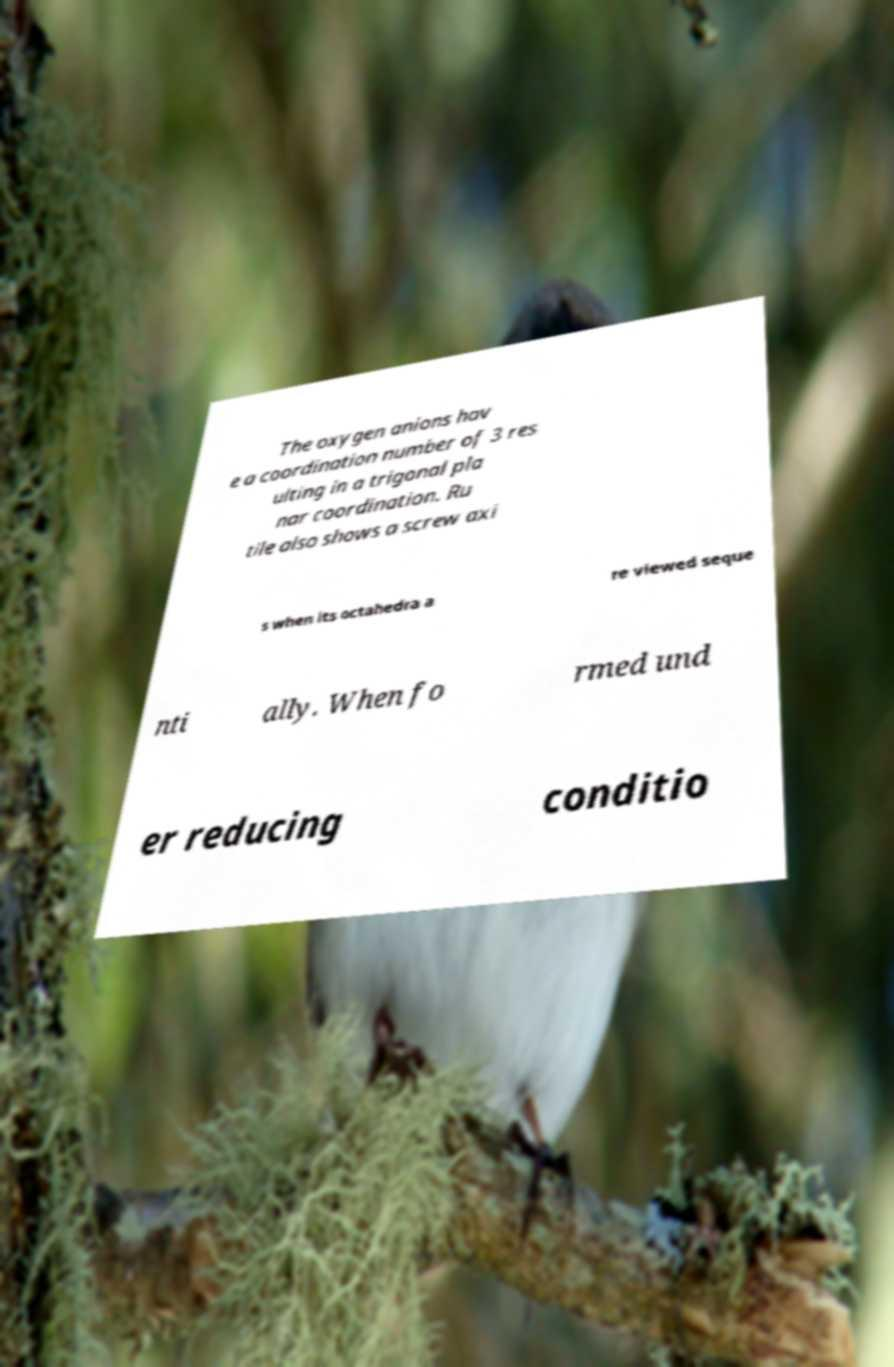Can you accurately transcribe the text from the provided image for me? The oxygen anions hav e a coordination number of 3 res ulting in a trigonal pla nar coordination. Ru tile also shows a screw axi s when its octahedra a re viewed seque nti ally. When fo rmed und er reducing conditio 